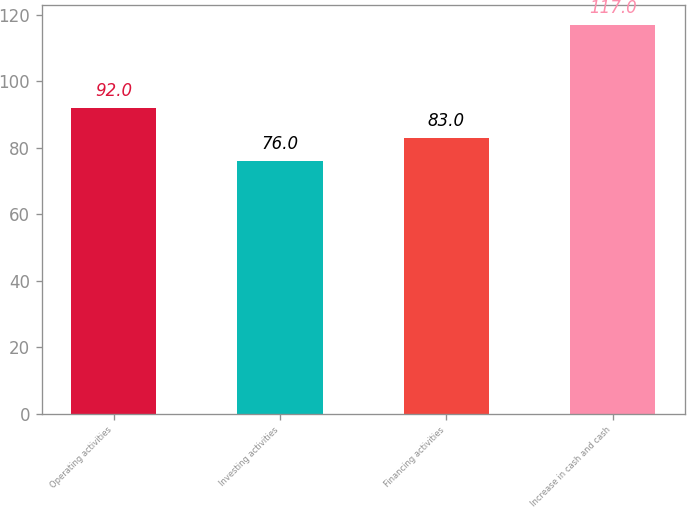Convert chart to OTSL. <chart><loc_0><loc_0><loc_500><loc_500><bar_chart><fcel>Operating activities<fcel>Investing activities<fcel>Financing activities<fcel>Increase in cash and cash<nl><fcel>92<fcel>76<fcel>83<fcel>117<nl></chart> 